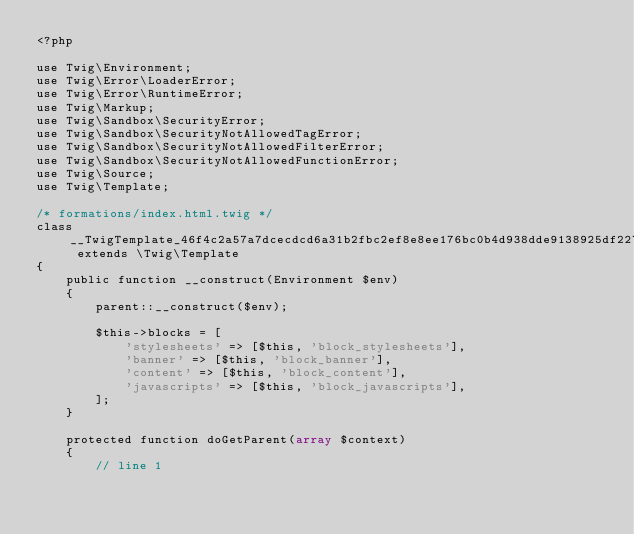Convert code to text. <code><loc_0><loc_0><loc_500><loc_500><_PHP_><?php

use Twig\Environment;
use Twig\Error\LoaderError;
use Twig\Error\RuntimeError;
use Twig\Markup;
use Twig\Sandbox\SecurityError;
use Twig\Sandbox\SecurityNotAllowedTagError;
use Twig\Sandbox\SecurityNotAllowedFilterError;
use Twig\Sandbox\SecurityNotAllowedFunctionError;
use Twig\Source;
use Twig\Template;

/* formations/index.html.twig */
class __TwigTemplate_46f4c2a57a7dcecdcd6a31b2fbc2ef8e8ee176bc0b4d938dde9138925df2274d extends \Twig\Template
{
    public function __construct(Environment $env)
    {
        parent::__construct($env);

        $this->blocks = [
            'stylesheets' => [$this, 'block_stylesheets'],
            'banner' => [$this, 'block_banner'],
            'content' => [$this, 'block_content'],
            'javascripts' => [$this, 'block_javascripts'],
        ];
    }

    protected function doGetParent(array $context)
    {
        // line 1</code> 